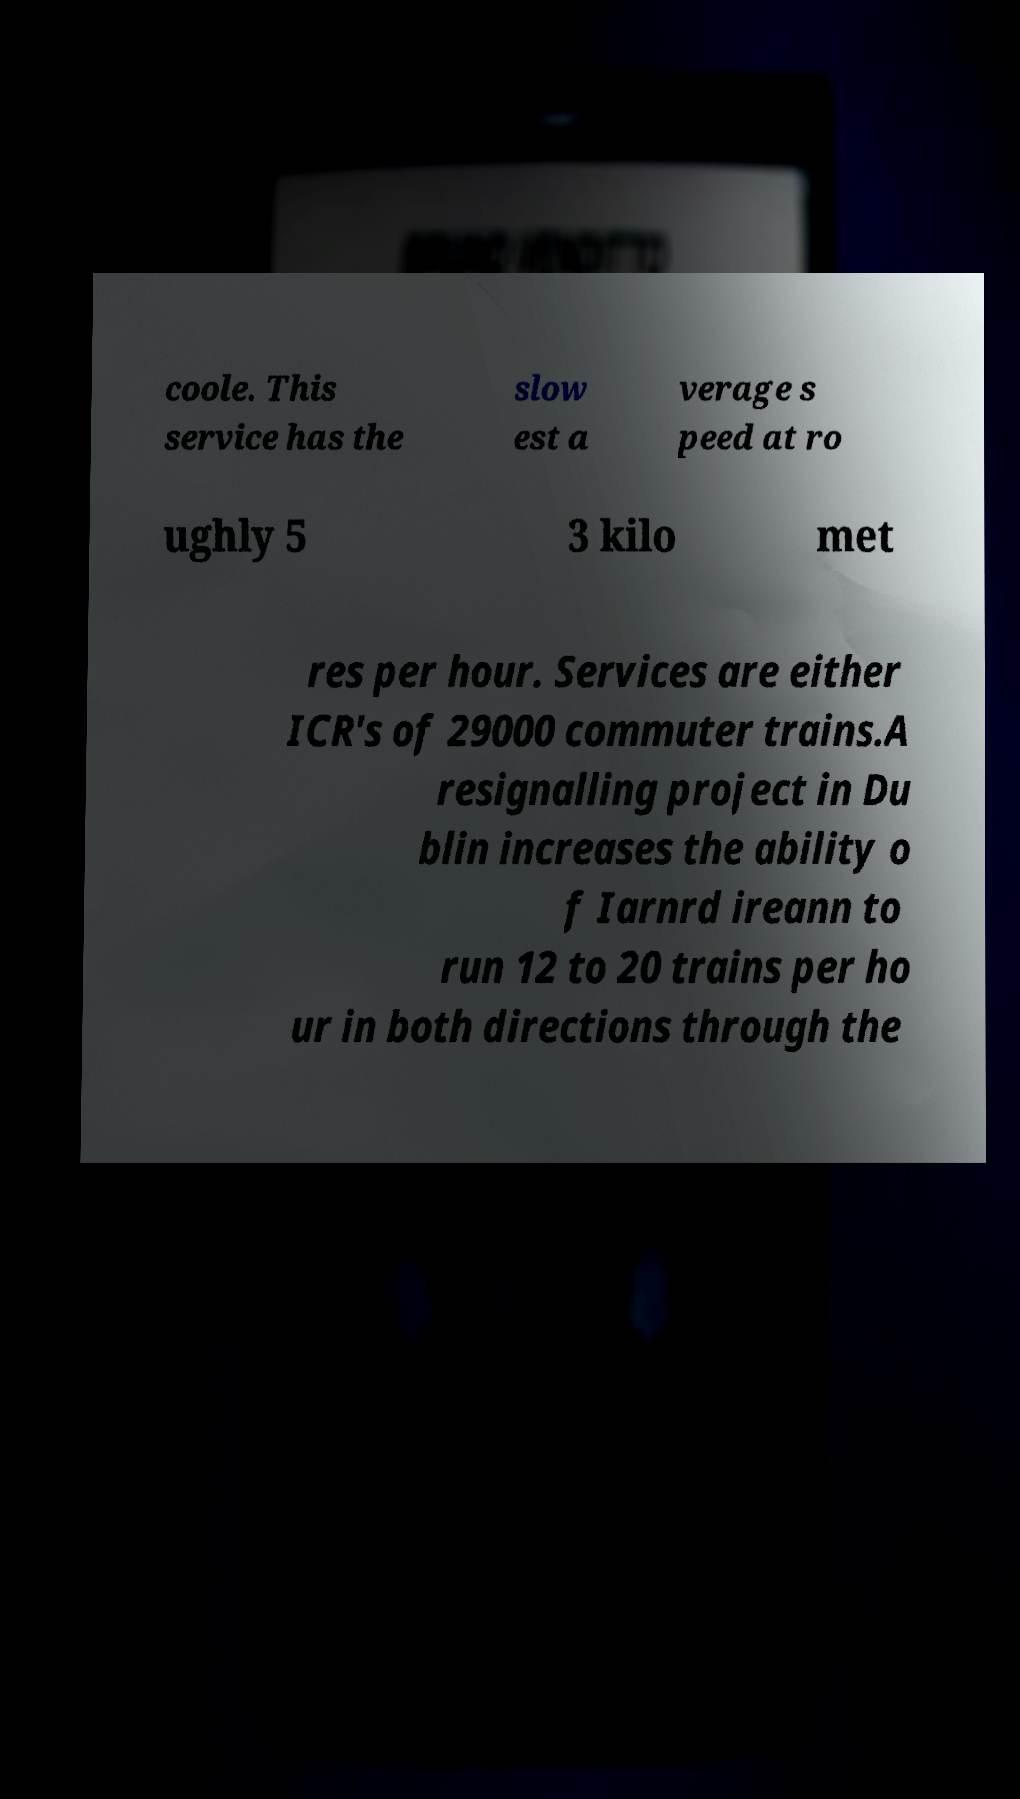Could you assist in decoding the text presented in this image and type it out clearly? coole. This service has the slow est a verage s peed at ro ughly 5 3 kilo met res per hour. Services are either ICR's of 29000 commuter trains.A resignalling project in Du blin increases the ability o f Iarnrd ireann to run 12 to 20 trains per ho ur in both directions through the 